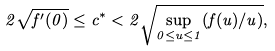<formula> <loc_0><loc_0><loc_500><loc_500>2 \sqrt { f ^ { \prime } ( 0 ) } \leq c ^ { * } < 2 \sqrt { \sup _ { 0 \leq u \leq 1 } ( f ( u ) / u ) } ,</formula> 